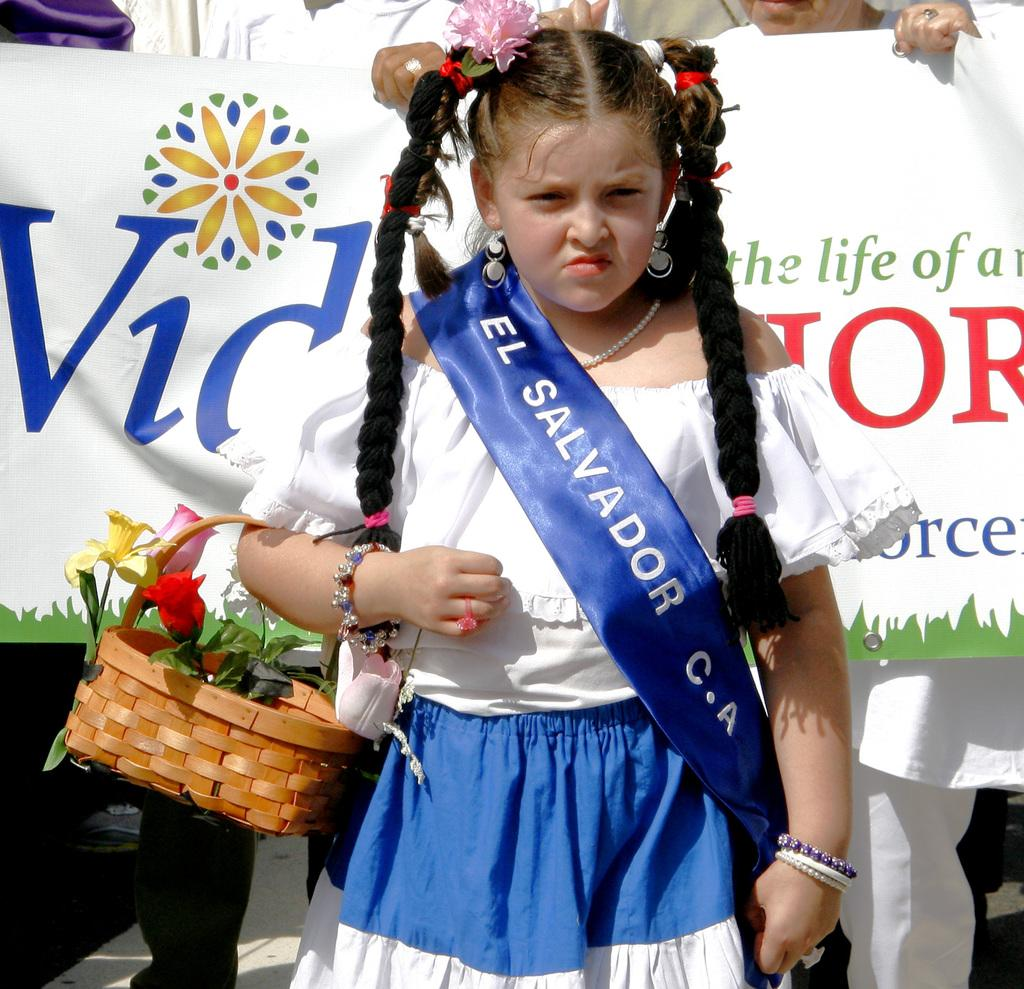<image>
Create a compact narrative representing the image presented. A girl in a sash that says El Salvador holds a basket on one arm. 